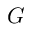<formula> <loc_0><loc_0><loc_500><loc_500>G</formula> 